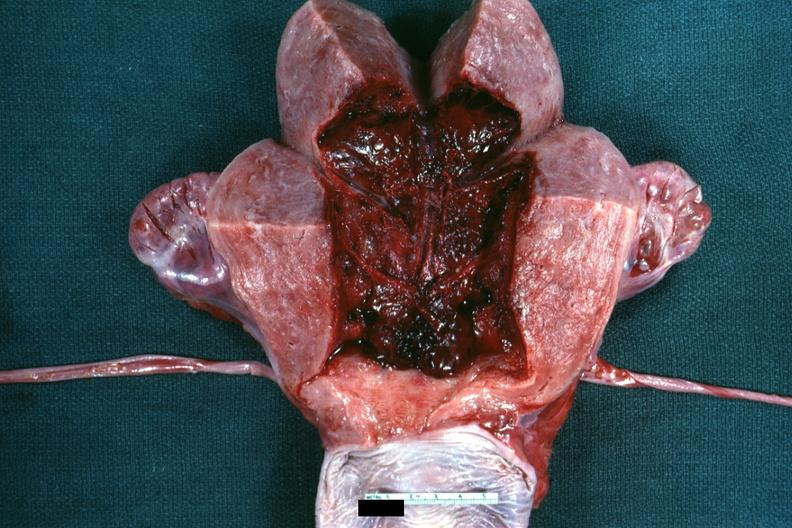does this image show 18 hours after cesarean section?
Answer the question using a single word or phrase. Yes 